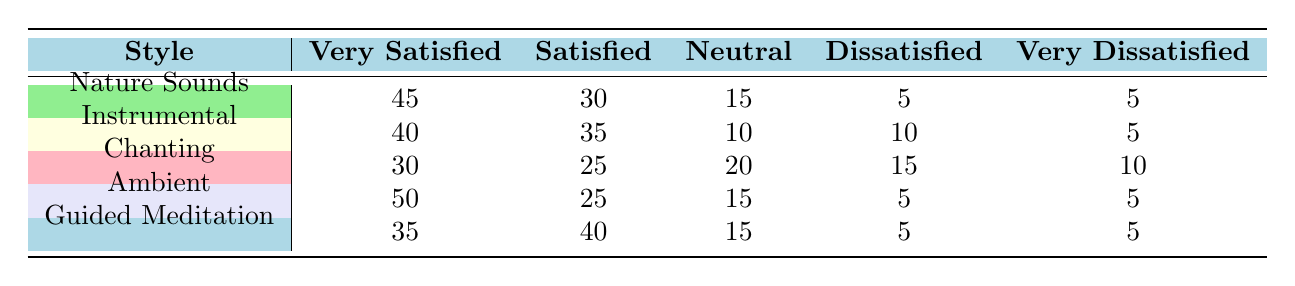What is the highest number of "very satisfied" listeners across all styles? The "Ambient" style has the highest number of "very satisfied" listeners, which is 50.
Answer: 50 What is the total number of listeners who were "satisfied" with "Instrumental" music? The number of "satisfied" listeners for "Instrumental" music is 35.
Answer: 35 Is there a meditation style where the number of "very dissatisfied" listeners is equal to or less than 5? Both "Nature Sounds," "Ambient," and "Guided Meditation" have 5 "very dissatisfied" listeners each, which is equal to 5.
Answer: Yes Which meditation style has the lowest number of "neutral" listeners? The "Instrumental" style has the lowest number of "neutral" listeners, with a total of 10.
Answer: 10 What is the combined number of "dissatisfied" listeners for "Chanting" and "Guided Meditation"? The "Chanting" style has 15 "dissatisfied" listeners and "Guided Meditation" has 5, combining these gives 15 + 5 = 20 dissatisfied listeners.
Answer: 20 What percentage of "very satisfied" listeners does "Nature Sounds" represent out of the total listeners for that style? The total number of listeners for "Nature Sounds" is 45 + 30 + 15 + 5 + 5 = 100. The "very satisfied" listeners are 45, making the percentage (45/100) * 100 = 45%.
Answer: 45% Which style has the largest difference between "very satisfied" and "dissatisfied" listeners? For "Ambient," the difference is 50 (very satisfied) - 5 (dissatisfied) = 45. For "Chanting," the difference is 30 - 15 = 15. Thus "Ambient" has the largest difference of 45.
Answer: 45 Are any meditation styles rated "neutral" by more listeners than "dissatisfied" listeners? "Chanting" has 20 "neutral" listeners compared to 15 "dissatisfied," and "Nature Sounds" has 15 "neutral" and 5 "dissatisfied," so yes, both "Chanting" and "Nature Sounds" fit this.
Answer: Yes What is the average number of "very satisfied" listeners across all meditation styles? The "very satisfied" listeners are: 45 (Nature Sounds) + 40 (Instrumental) + 30 (Chanting) + 50 (Ambient) + 35 (Guided Meditation) = 200. There are 5 styles, so the average is 200/5 = 40.
Answer: 40 